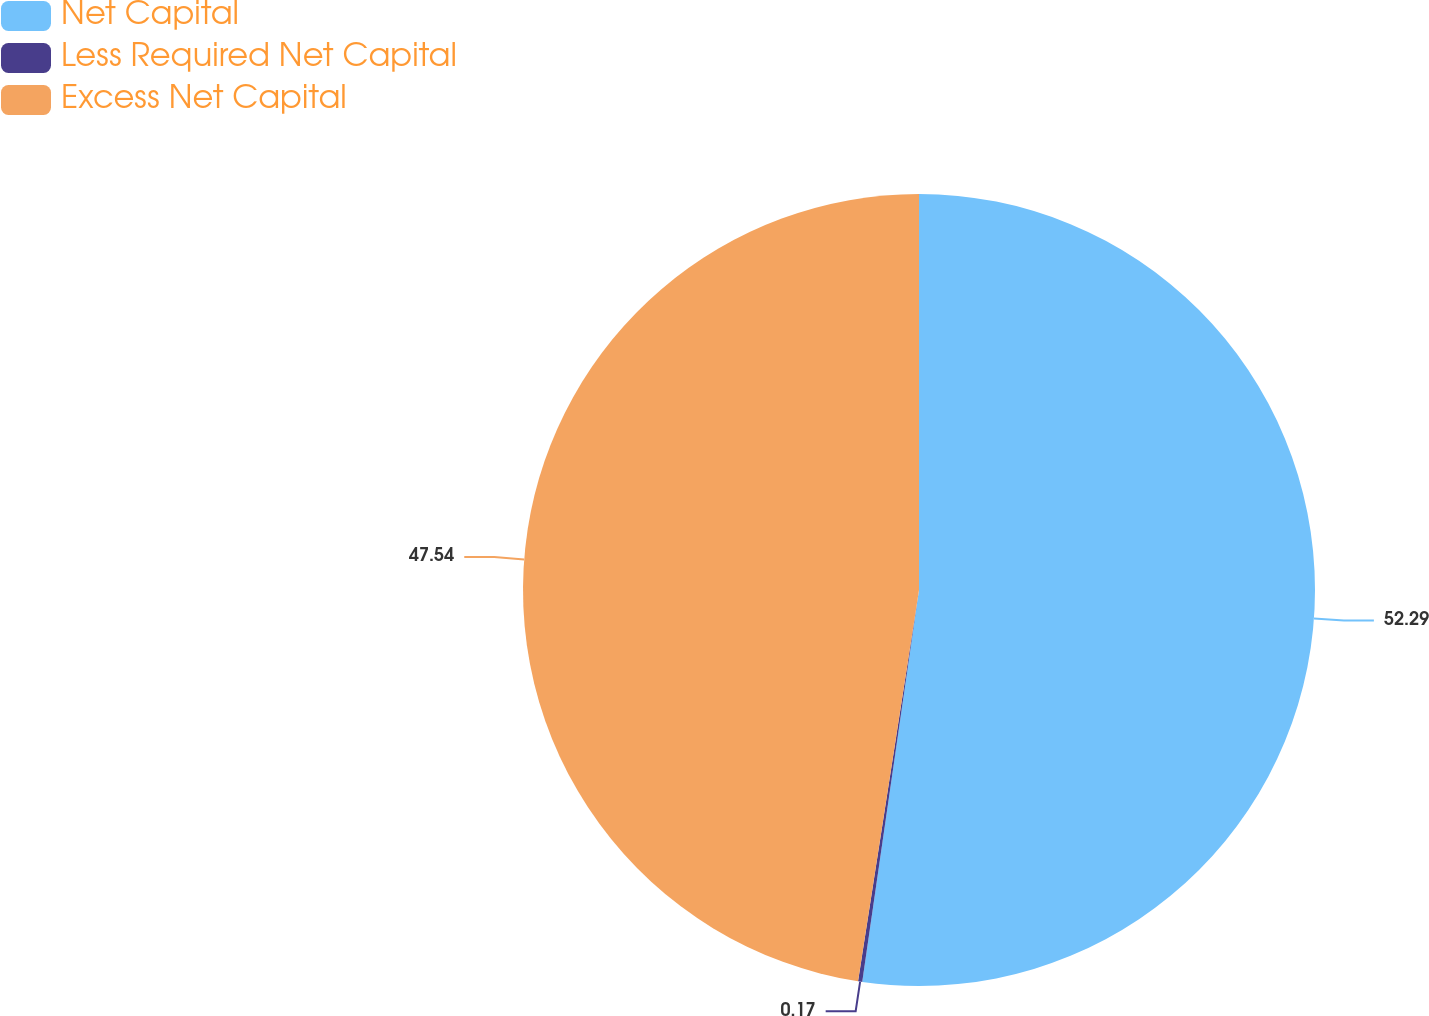<chart> <loc_0><loc_0><loc_500><loc_500><pie_chart><fcel>Net Capital<fcel>Less Required Net Capital<fcel>Excess Net Capital<nl><fcel>52.29%<fcel>0.17%<fcel>47.54%<nl></chart> 